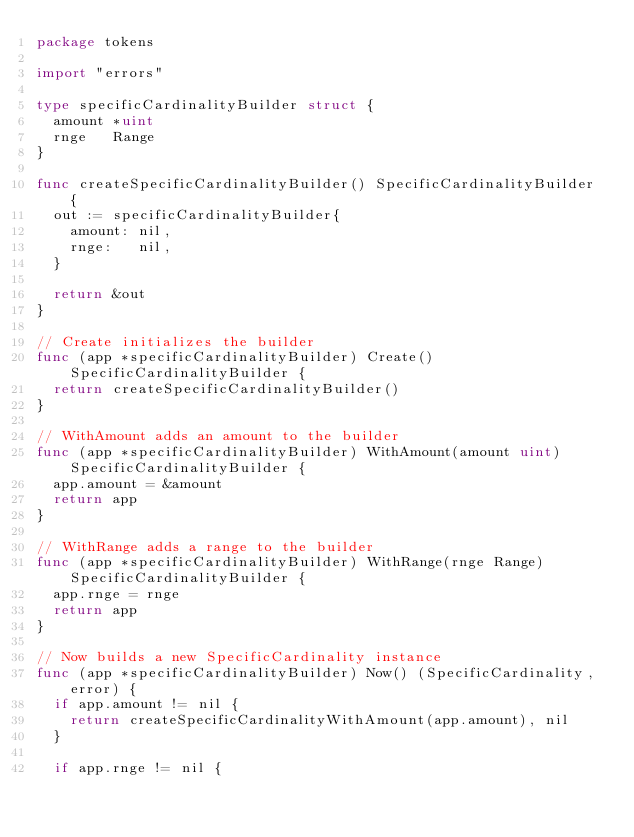<code> <loc_0><loc_0><loc_500><loc_500><_Go_>package tokens

import "errors"

type specificCardinalityBuilder struct {
	amount *uint
	rnge   Range
}

func createSpecificCardinalityBuilder() SpecificCardinalityBuilder {
	out := specificCardinalityBuilder{
		amount: nil,
		rnge:   nil,
	}

	return &out
}

// Create initializes the builder
func (app *specificCardinalityBuilder) Create() SpecificCardinalityBuilder {
	return createSpecificCardinalityBuilder()
}

// WithAmount adds an amount to the builder
func (app *specificCardinalityBuilder) WithAmount(amount uint) SpecificCardinalityBuilder {
	app.amount = &amount
	return app
}

// WithRange adds a range to the builder
func (app *specificCardinalityBuilder) WithRange(rnge Range) SpecificCardinalityBuilder {
	app.rnge = rnge
	return app
}

// Now builds a new SpecificCardinality instance
func (app *specificCardinalityBuilder) Now() (SpecificCardinality, error) {
	if app.amount != nil {
		return createSpecificCardinalityWithAmount(app.amount), nil
	}

	if app.rnge != nil {</code> 